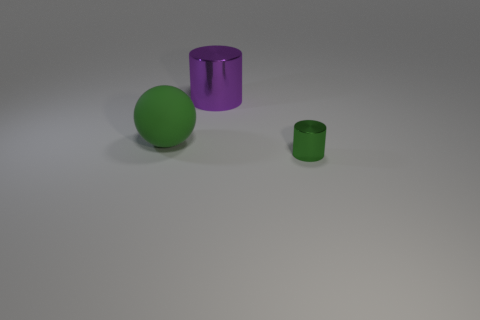Add 3 big brown rubber spheres. How many objects exist? 6 Subtract all cylinders. How many objects are left? 1 Add 2 big metal objects. How many big metal objects exist? 3 Subtract 0 gray cubes. How many objects are left? 3 Subtract all small green cylinders. Subtract all big cylinders. How many objects are left? 1 Add 1 purple metal objects. How many purple metal objects are left? 2 